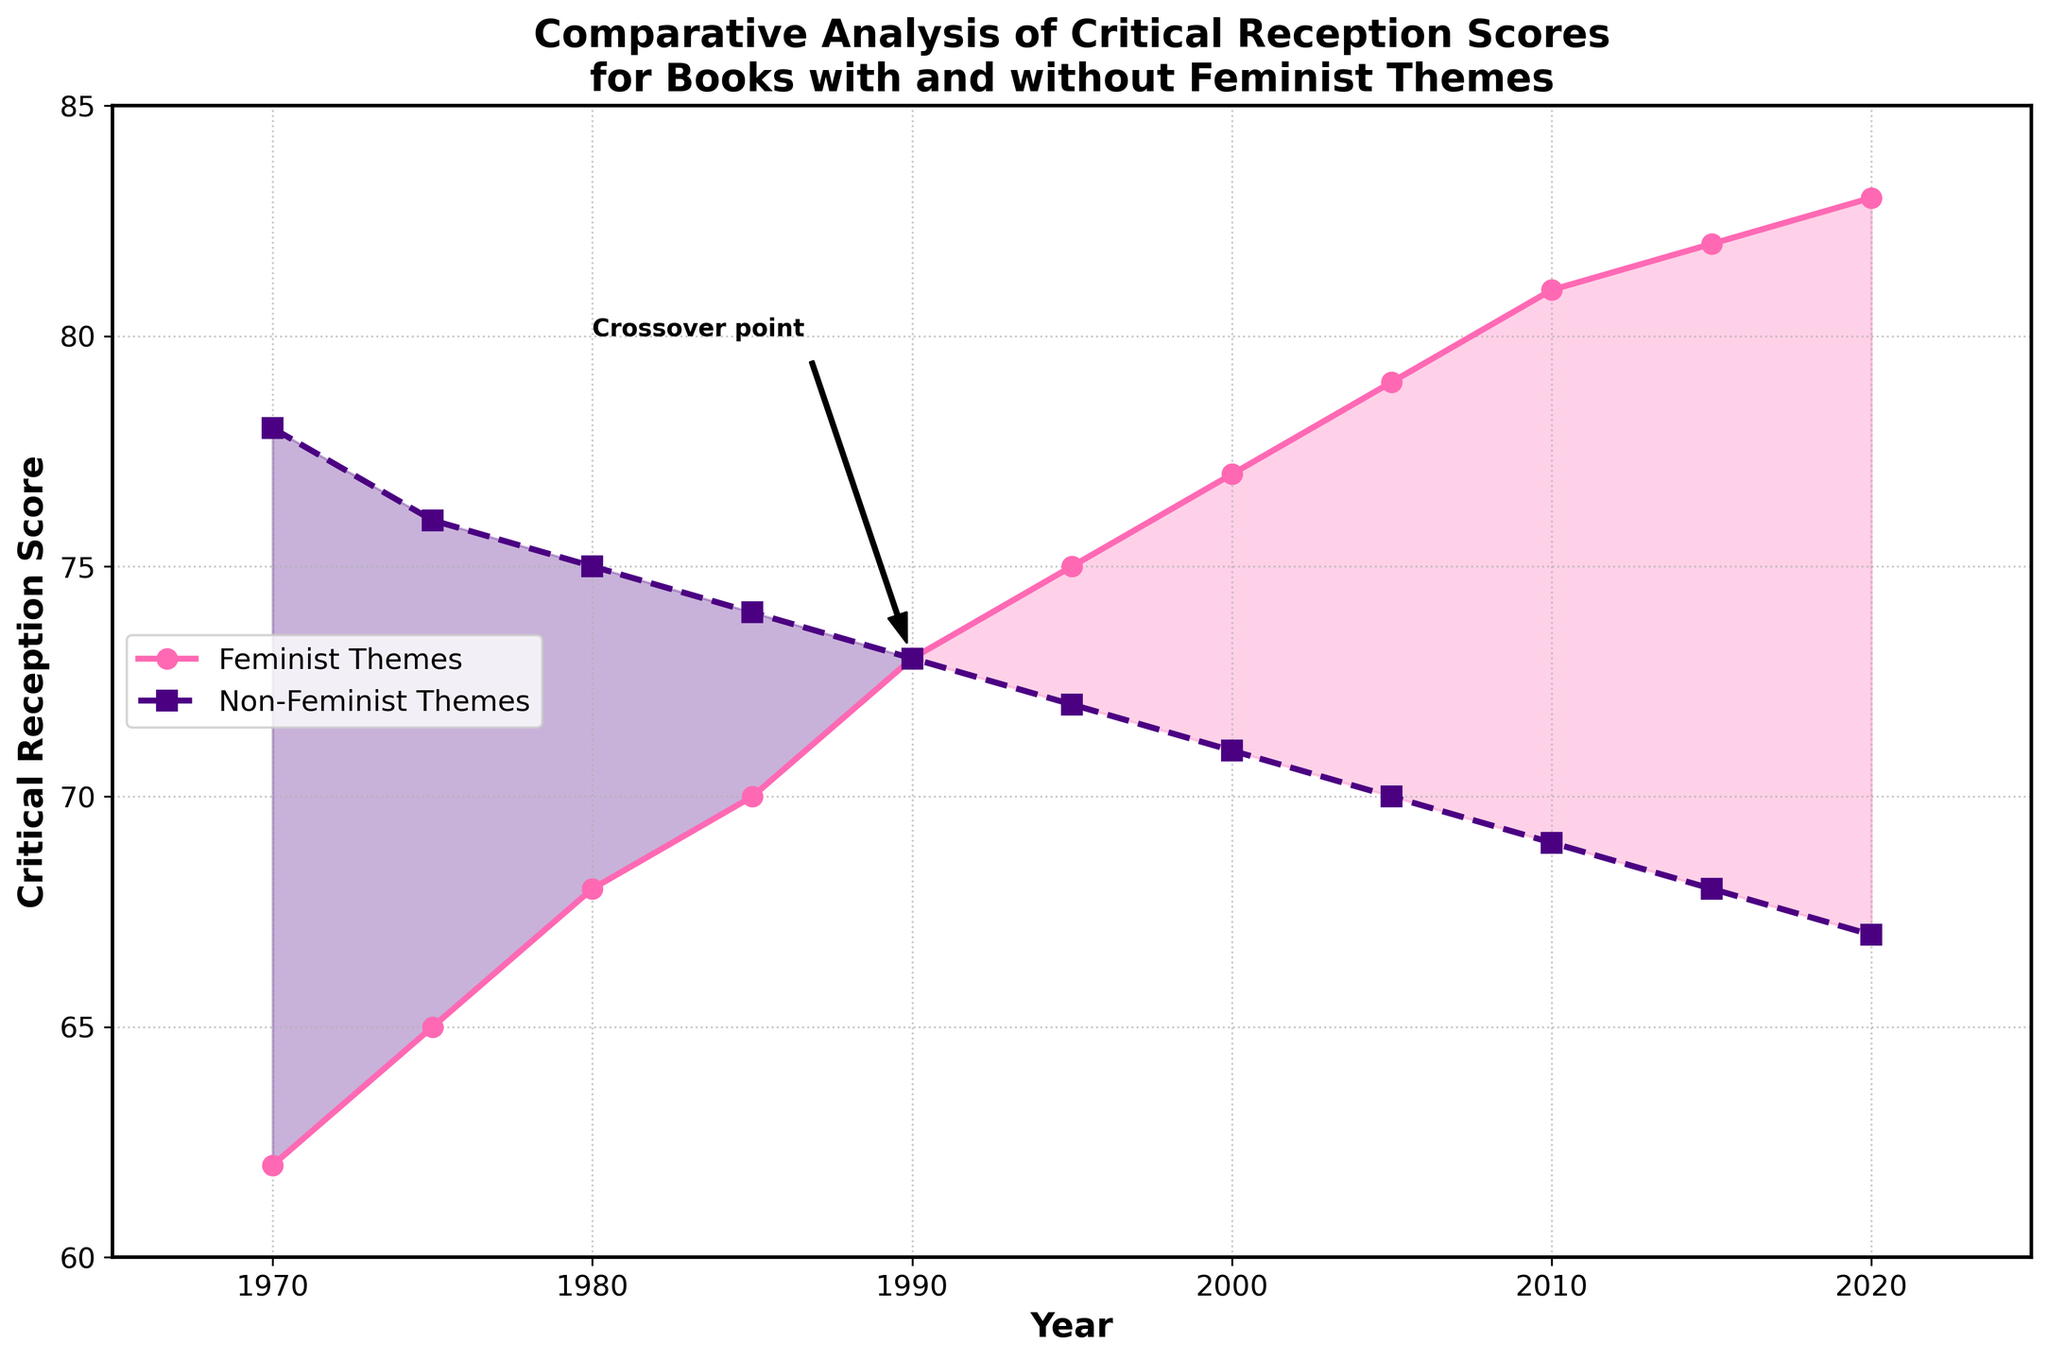What year does the divergent trend start between reception scores of books with and without feminist themes? By observing the annotated crossover point on the graph, you can see that the divergence starts in the year 1990. Both lines (feminist and non-feminist themes scores) transition at the same score, revealing the shift point.
Answer: 1990 What is the general trend for books with feminist themes from 1970 to 2020? By analyzing the line representing books with feminist themes, you notice it consistently increases over time. Starting from 62 in 1970 and rising up to 83 in 2020, the trend indicates a positive and steady upward climb.
Answer: Increasing Which year has the highest critical reception score for books with non-feminist themes? Looking at the highest point on the line representing non-feminist themes, the score peaks at 78 in the year 1970. Therefore, 1970 is the year with the highest reception.
Answer: 1970 What is the difference in critical reception scores between books with feminist themes and non-feminist themes in 2020? By subtracting the non-feminist score (67) from the feminist score (83), the difference in scores for the year 2020 is calculated as 83 - 67.
Answer: 16 During which years were books with non-feminist themes rated higher than books with feminist themes? By observing the chart, the intersection point marks the change in superior scores. Before 1990 (i.e., from 1970 to 1985), books with non-feminist themes have consistently higher scores than feminist ones.
Answer: 1970 to 1985 How does the gap between the scores of books with feminist themes and non-feminist themes change over the years? Initially, the gap narrows up until 1990 when the scores intersect. Post-1990, the gap widens as books with feminist themes garner progressively higher scores, showing more substantial increases compared to non-feminist themes.
Answer: Narrows then widens In what year do books with feminist themes exceed a critical reception score of 80 for the first time? Observing the chart line for feminist themes, the year when it surpasses 80 is noted. The score first exceeds 80 in the year 2010.
Answer: 2010 Which color area signifies the periods where feminist-themed books have higher scores, and what does this reveal visually about these periods? The area under the pink fill represents periods where feminist-themed books score higher. Visually, this shows dominance in the reception of feminist-themed books during these parts of the graph post-1990.
Answer: Pink Area What annotation is present on the chart, and what does it indicate? The annotation "Crossover point" is marked with an arrow, pointing to the place where the scores of the two categories meet at 1990, indicating the point where feminist-themed books' scores begin to surpass non-feminist ones.
Answer: Crossover point, 1990 How much did the score for books with feminist themes grow from 1970 to 1985? Subtracting the 1970 score (62) from the 1985 score (70) to determine the increase shows an 8-point rise over those years.
Answer: 8 